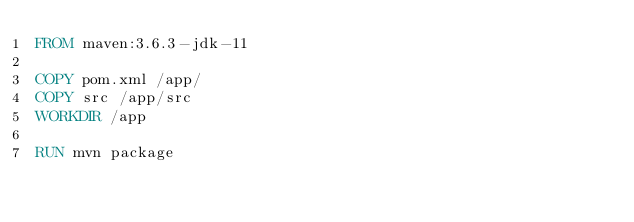<code> <loc_0><loc_0><loc_500><loc_500><_Dockerfile_>FROM maven:3.6.3-jdk-11

COPY pom.xml /app/
COPY src /app/src
WORKDIR /app

RUN mvn package</code> 